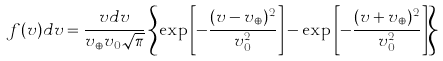<formula> <loc_0><loc_0><loc_500><loc_500>f ( v ) d v = \frac { v d v } { v _ { \oplus } v _ { 0 } \sqrt { \pi } } \left \{ \exp \left [ - \frac { ( v - v _ { \oplus } ) ^ { 2 } } { v _ { 0 } ^ { 2 } } \right ] - \exp \left [ - \frac { ( v + v _ { \oplus } ) ^ { 2 } } { v _ { 0 } ^ { 2 } } \right ] \right \}</formula> 